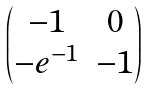<formula> <loc_0><loc_0><loc_500><loc_500>\begin{pmatrix} - 1 & 0 \\ - e ^ { - 1 } & - 1 \end{pmatrix}</formula> 